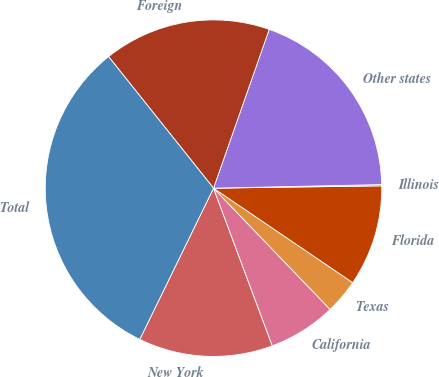<chart> <loc_0><loc_0><loc_500><loc_500><pie_chart><fcel>New York<fcel>California<fcel>Texas<fcel>Florida<fcel>Illinois<fcel>Other states<fcel>Foreign<fcel>Total<nl><fcel>12.9%<fcel>6.51%<fcel>3.32%<fcel>9.71%<fcel>0.12%<fcel>19.29%<fcel>16.09%<fcel>32.06%<nl></chart> 